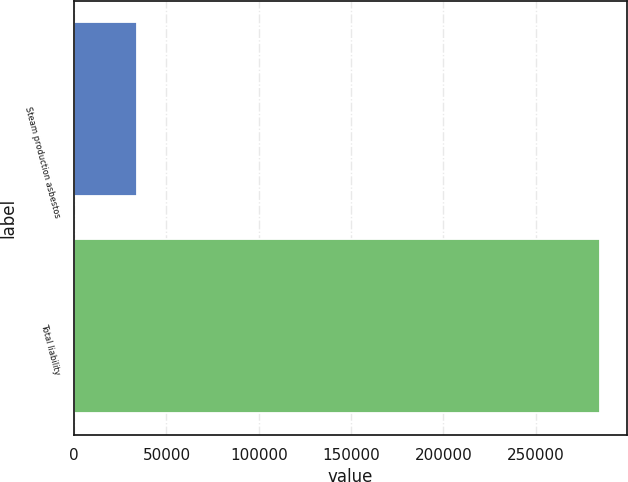Convert chart. <chart><loc_0><loc_0><loc_500><loc_500><bar_chart><fcel>Steam production asbestos<fcel>Total liability<nl><fcel>33948<fcel>284990<nl></chart> 